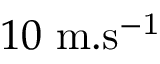Convert formula to latex. <formula><loc_0><loc_0><loc_500><loc_500>1 0 \ m . s ^ { - 1 }</formula> 